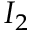<formula> <loc_0><loc_0><loc_500><loc_500>{ I } _ { 2 }</formula> 